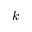<formula> <loc_0><loc_0><loc_500><loc_500>k</formula> 